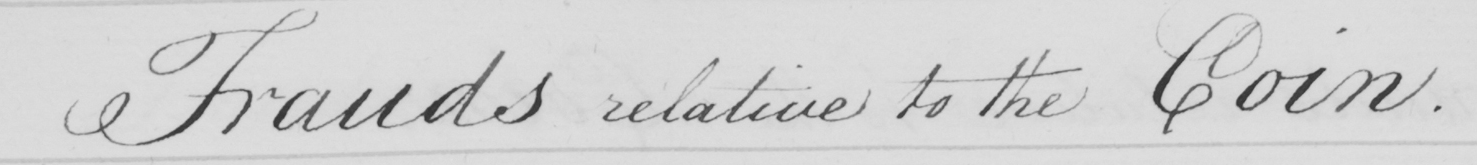Please provide the text content of this handwritten line. Frauds relative to the Coin . 